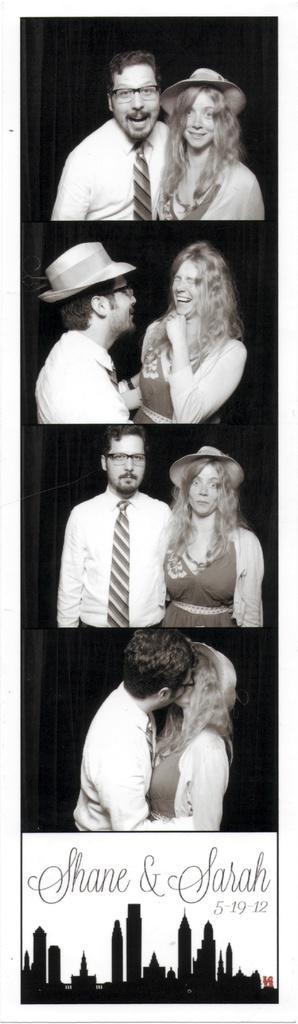Describe this image in one or two sentences. This is a edited image. In this image men and women were standing on the floor and they both were laughing and at the bottom of the image there are buildings. 